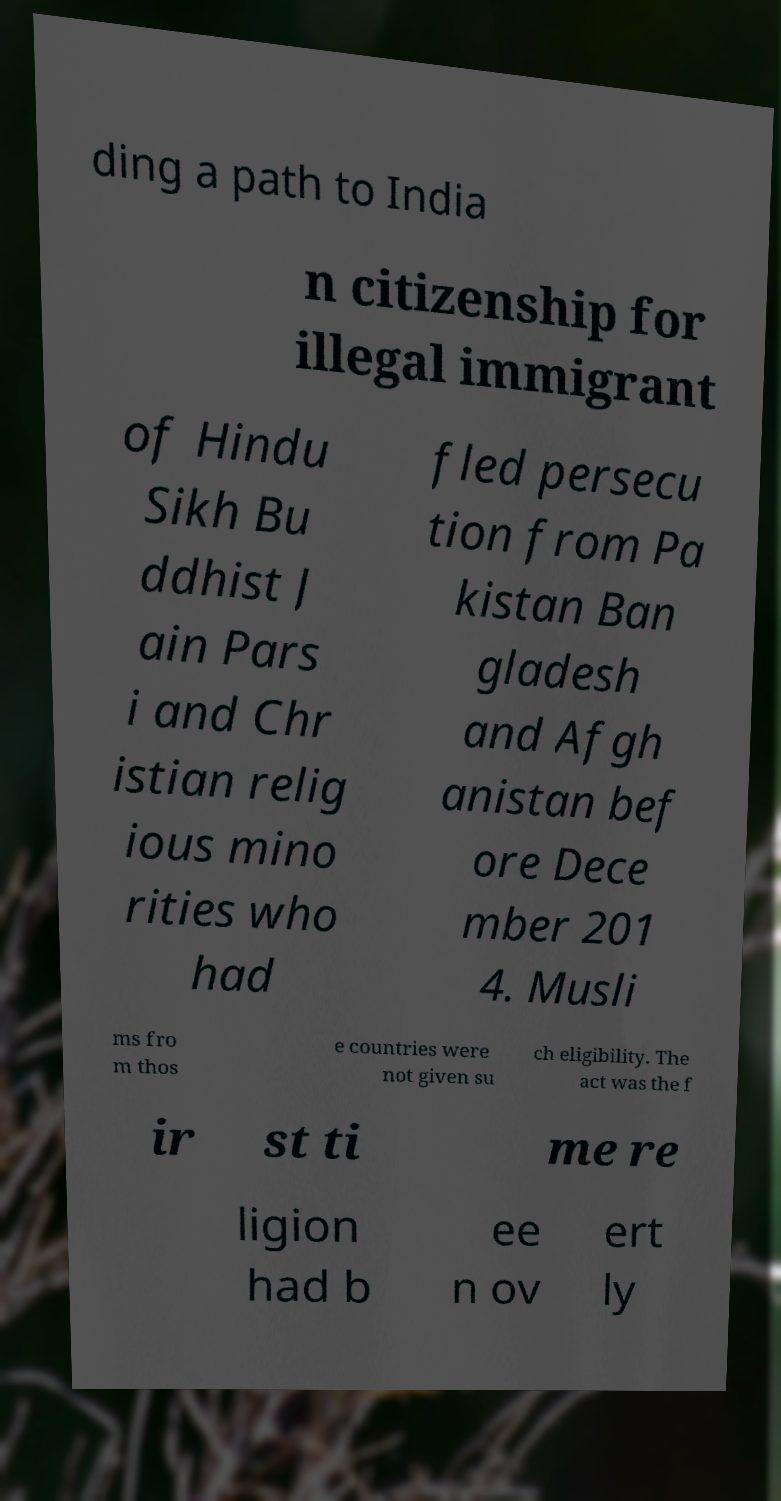Please identify and transcribe the text found in this image. ding a path to India n citizenship for illegal immigrant of Hindu Sikh Bu ddhist J ain Pars i and Chr istian relig ious mino rities who had fled persecu tion from Pa kistan Ban gladesh and Afgh anistan bef ore Dece mber 201 4. Musli ms fro m thos e countries were not given su ch eligibility. The act was the f ir st ti me re ligion had b ee n ov ert ly 